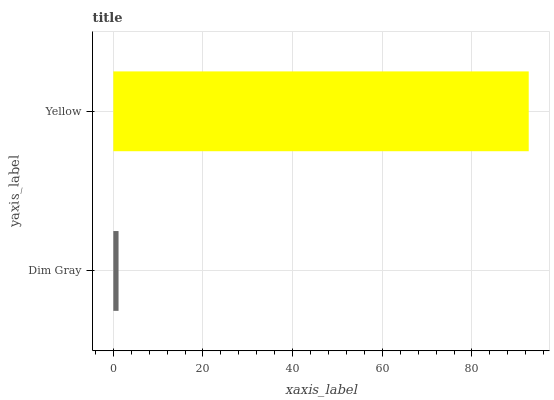Is Dim Gray the minimum?
Answer yes or no. Yes. Is Yellow the maximum?
Answer yes or no. Yes. Is Yellow the minimum?
Answer yes or no. No. Is Yellow greater than Dim Gray?
Answer yes or no. Yes. Is Dim Gray less than Yellow?
Answer yes or no. Yes. Is Dim Gray greater than Yellow?
Answer yes or no. No. Is Yellow less than Dim Gray?
Answer yes or no. No. Is Yellow the high median?
Answer yes or no. Yes. Is Dim Gray the low median?
Answer yes or no. Yes. Is Dim Gray the high median?
Answer yes or no. No. Is Yellow the low median?
Answer yes or no. No. 